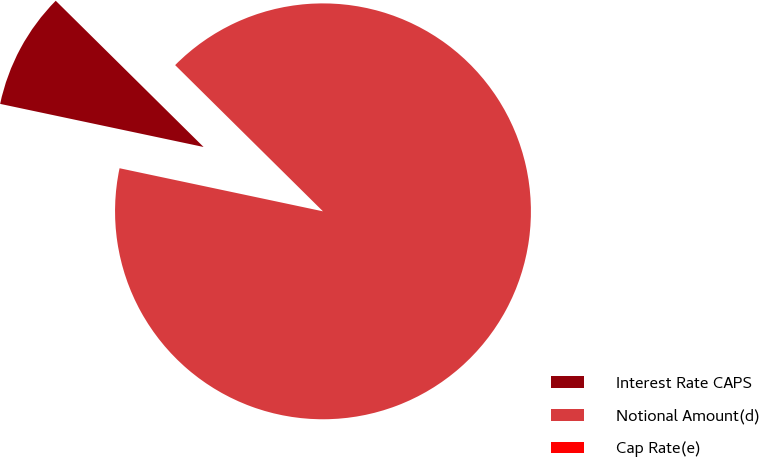<chart> <loc_0><loc_0><loc_500><loc_500><pie_chart><fcel>Interest Rate CAPS<fcel>Notional Amount(d)<fcel>Cap Rate(e)<nl><fcel>9.09%<fcel>90.91%<fcel>0.0%<nl></chart> 